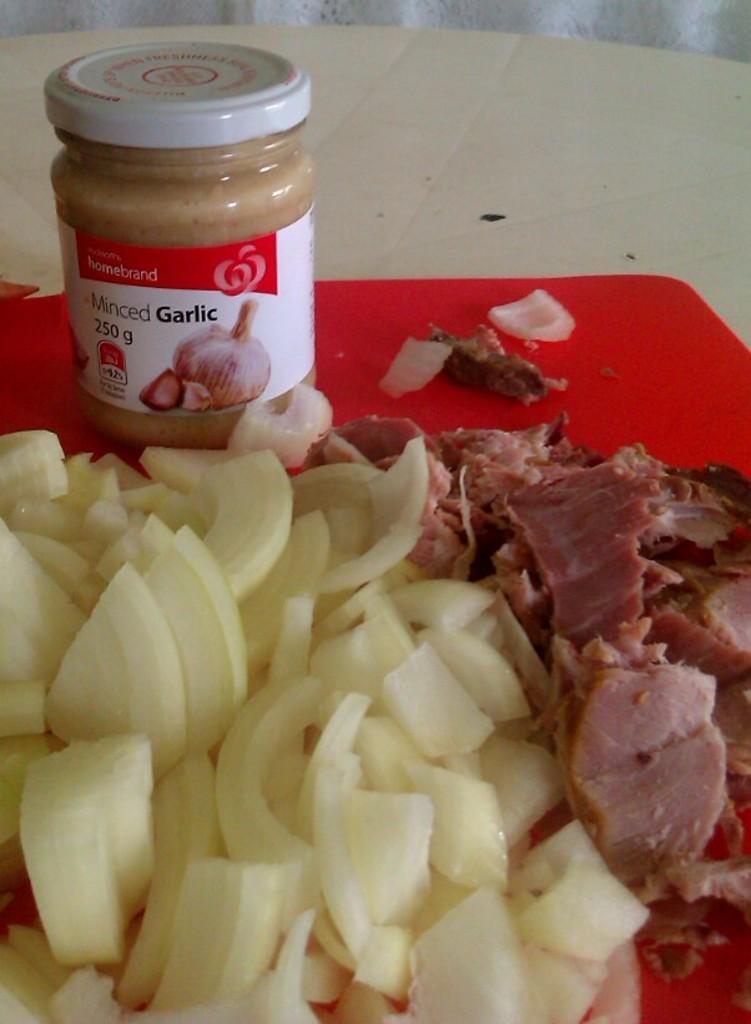Can you describe this image briefly? In this picture I can see slices of a food item and meat, there is a plastic container with garlic paste in it, on the board, on the table. 